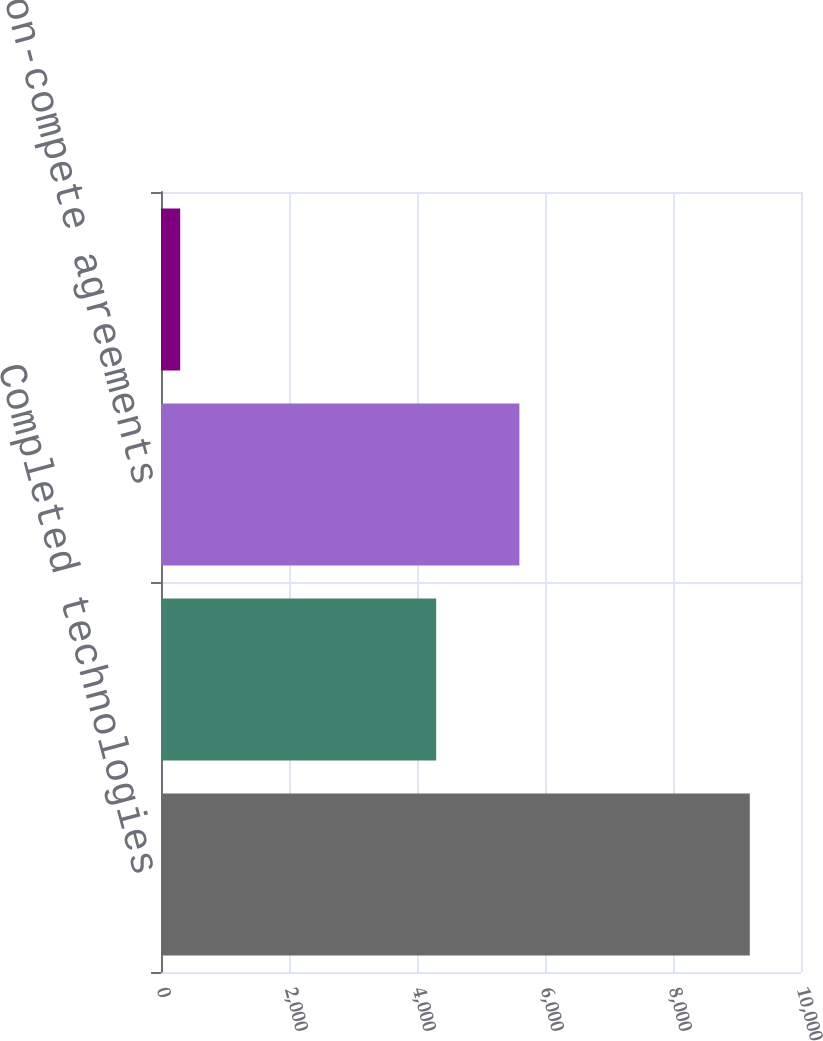Convert chart to OTSL. <chart><loc_0><loc_0><loc_500><loc_500><bar_chart><fcel>Completed technologies<fcel>Customer relationships<fcel>Non-compete agreements<fcel>Trade names<nl><fcel>9200<fcel>4300<fcel>5600<fcel>300<nl></chart> 